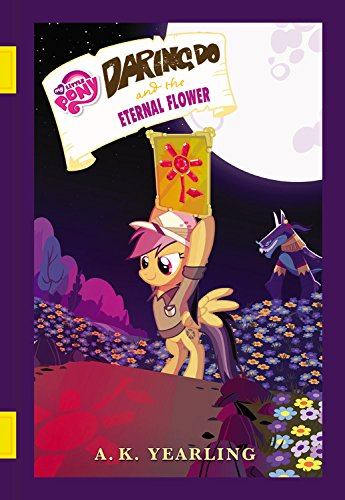Is this a kids book? Yes, it is indeed a kids' book, part of the My Little Pony franchise, known for its appeal to young audiences with its adventurous themes and vibrant characters. 